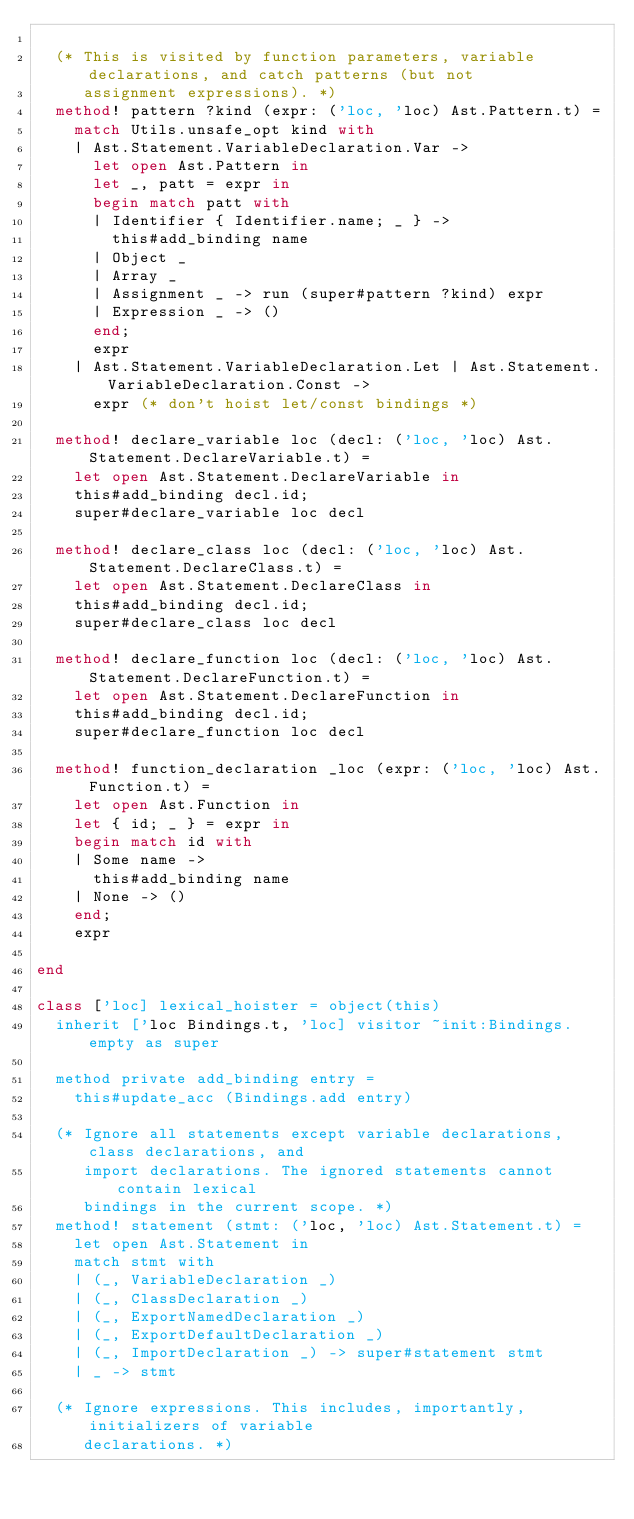Convert code to text. <code><loc_0><loc_0><loc_500><loc_500><_OCaml_>
  (* This is visited by function parameters, variable declarations, and catch patterns (but not
     assignment expressions). *)
  method! pattern ?kind (expr: ('loc, 'loc) Ast.Pattern.t) =
    match Utils.unsafe_opt kind with
    | Ast.Statement.VariableDeclaration.Var ->
      let open Ast.Pattern in
      let _, patt = expr in
      begin match patt with
      | Identifier { Identifier.name; _ } ->
        this#add_binding name
      | Object _
      | Array _
      | Assignment _ -> run (super#pattern ?kind) expr
      | Expression _ -> ()
      end;
      expr
    | Ast.Statement.VariableDeclaration.Let | Ast.Statement.VariableDeclaration.Const ->
      expr (* don't hoist let/const bindings *)

  method! declare_variable loc (decl: ('loc, 'loc) Ast.Statement.DeclareVariable.t) =
    let open Ast.Statement.DeclareVariable in
    this#add_binding decl.id;
    super#declare_variable loc decl

  method! declare_class loc (decl: ('loc, 'loc) Ast.Statement.DeclareClass.t) =
    let open Ast.Statement.DeclareClass in
    this#add_binding decl.id;
    super#declare_class loc decl

  method! declare_function loc (decl: ('loc, 'loc) Ast.Statement.DeclareFunction.t) =
    let open Ast.Statement.DeclareFunction in
    this#add_binding decl.id;
    super#declare_function loc decl

  method! function_declaration _loc (expr: ('loc, 'loc) Ast.Function.t) =
    let open Ast.Function in
    let { id; _ } = expr in
    begin match id with
    | Some name ->
      this#add_binding name
    | None -> ()
    end;
    expr

end

class ['loc] lexical_hoister = object(this)
  inherit ['loc Bindings.t, 'loc] visitor ~init:Bindings.empty as super

  method private add_binding entry =
    this#update_acc (Bindings.add entry)

  (* Ignore all statements except variable declarations, class declarations, and
     import declarations. The ignored statements cannot contain lexical
     bindings in the current scope. *)
  method! statement (stmt: ('loc, 'loc) Ast.Statement.t) =
    let open Ast.Statement in
    match stmt with
    | (_, VariableDeclaration _)
    | (_, ClassDeclaration _)
    | (_, ExportNamedDeclaration _)
    | (_, ExportDefaultDeclaration _)
    | (_, ImportDeclaration _) -> super#statement stmt
    | _ -> stmt

  (* Ignore expressions. This includes, importantly, initializers of variable
     declarations. *)</code> 